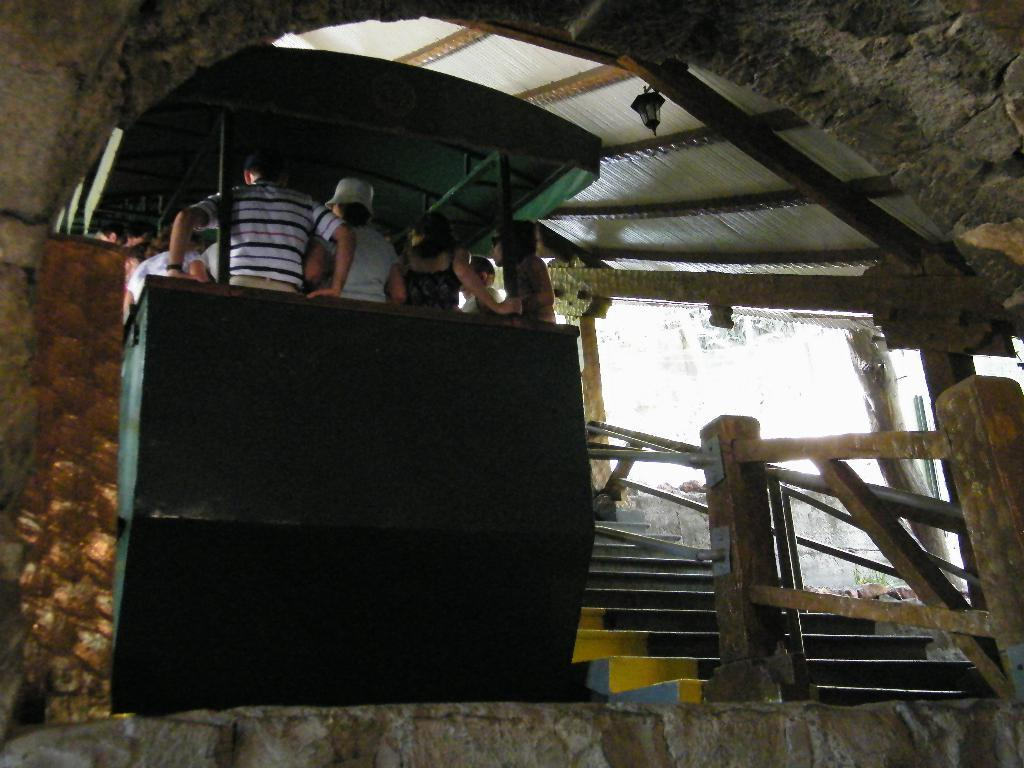What is happening in the middle of the image? There are people standing in the middle of the image. What architectural feature is located beside the people? There are steps beside the people. What type of barrier is present beside the steps? There is fencing beside the steps. What part of a building can be seen at the top of the image? There is a roof visible at the top of the image. What type of competition is taking place on the earth in the image? There is no competition or reference to the earth in the image; it simply shows people standing near steps and fencing. 